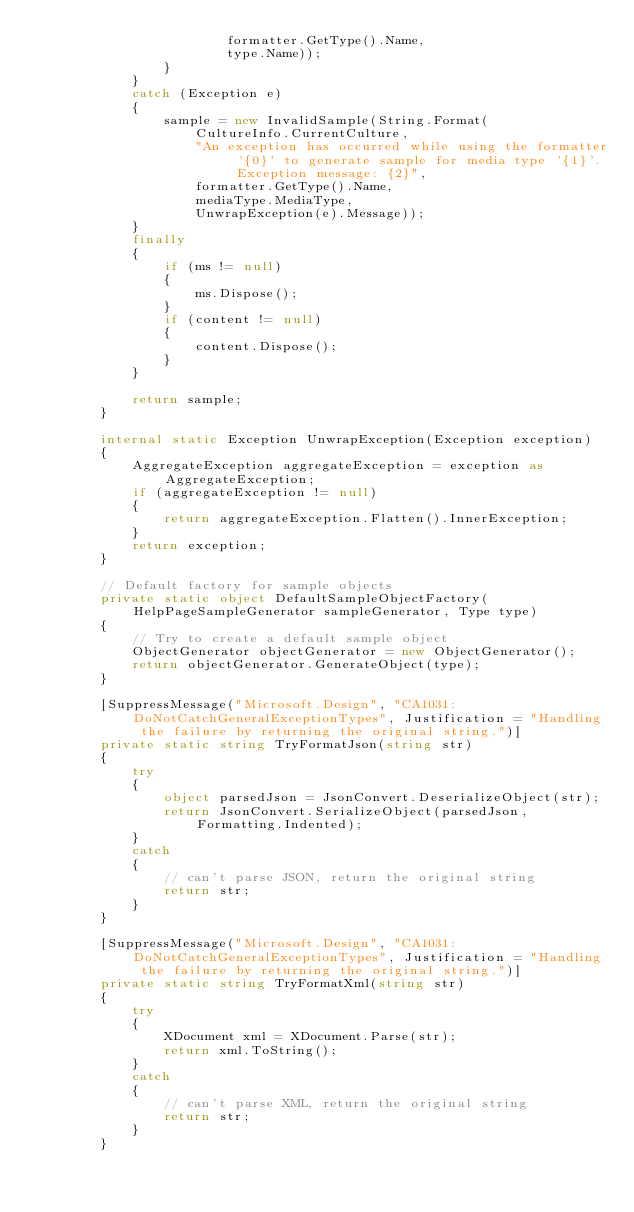Convert code to text. <code><loc_0><loc_0><loc_500><loc_500><_C#_>                        formatter.GetType().Name,
                        type.Name));
                }
            }
            catch (Exception e)
            {
                sample = new InvalidSample(String.Format(
                    CultureInfo.CurrentCulture,
                    "An exception has occurred while using the formatter '{0}' to generate sample for media type '{1}'. Exception message: {2}",
                    formatter.GetType().Name,
                    mediaType.MediaType,
                    UnwrapException(e).Message));
            }
            finally
            {
                if (ms != null)
                {
                    ms.Dispose();
                }
                if (content != null)
                {
                    content.Dispose();
                }
            }

            return sample;
        }

        internal static Exception UnwrapException(Exception exception)
        {
            AggregateException aggregateException = exception as AggregateException;
            if (aggregateException != null)
            {
                return aggregateException.Flatten().InnerException;
            }
            return exception;
        }

        // Default factory for sample objects
        private static object DefaultSampleObjectFactory(HelpPageSampleGenerator sampleGenerator, Type type)
        {
            // Try to create a default sample object
            ObjectGenerator objectGenerator = new ObjectGenerator();
            return objectGenerator.GenerateObject(type);
        }

        [SuppressMessage("Microsoft.Design", "CA1031:DoNotCatchGeneralExceptionTypes", Justification = "Handling the failure by returning the original string.")]
        private static string TryFormatJson(string str)
        {
            try
            {
                object parsedJson = JsonConvert.DeserializeObject(str);
                return JsonConvert.SerializeObject(parsedJson, Formatting.Indented);
            }
            catch
            {
                // can't parse JSON, return the original string
                return str;
            }
        }

        [SuppressMessage("Microsoft.Design", "CA1031:DoNotCatchGeneralExceptionTypes", Justification = "Handling the failure by returning the original string.")]
        private static string TryFormatXml(string str)
        {
            try
            {
                XDocument xml = XDocument.Parse(str);
                return xml.ToString();
            }
            catch
            {
                // can't parse XML, return the original string
                return str;
            }
        }
</code> 